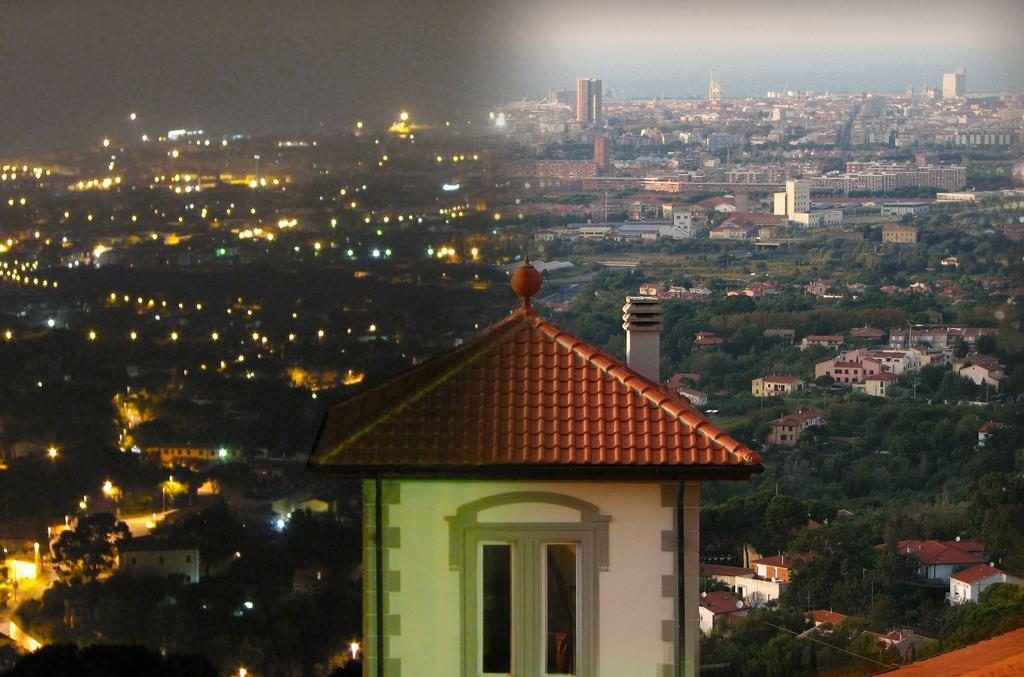What is the main subject in the center of the image? There is a house in the center of the image. What can be seen in the background of the image? There are trees, buildings, and lights in the background of the image. What type of profit can be seen in the image? There is no mention of profit in the image, as it features a house, trees, buildings, and lights. 